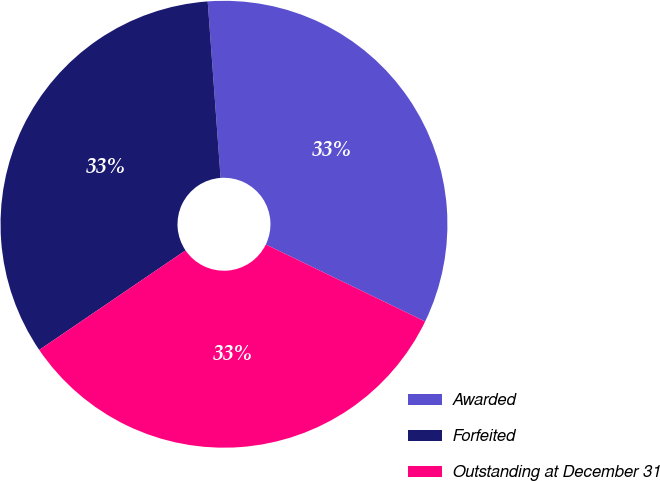Convert chart to OTSL. <chart><loc_0><loc_0><loc_500><loc_500><pie_chart><fcel>Awarded<fcel>Forfeited<fcel>Outstanding at December 31<nl><fcel>33.33%<fcel>33.35%<fcel>33.33%<nl></chart> 